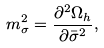Convert formula to latex. <formula><loc_0><loc_0><loc_500><loc_500>m ^ { 2 } _ { \sigma } = \frac { \partial ^ { 2 } \Omega _ { h } } { \partial \bar { \sigma } ^ { 2 } } ,</formula> 